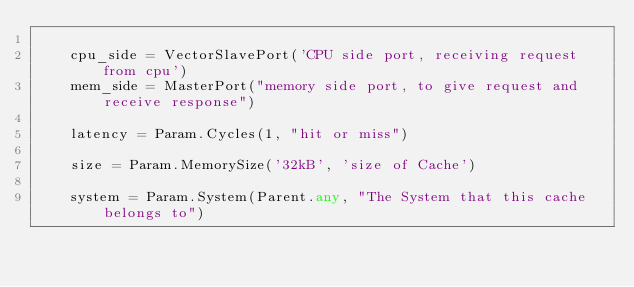<code> <loc_0><loc_0><loc_500><loc_500><_Python_>
    cpu_side = VectorSlavePort('CPU side port, receiving request from cpu')
    mem_side = MasterPort("memory side port, to give request and receive response")

    latency = Param.Cycles(1, "hit or miss")

    size = Param.MemorySize('32kB', 'size of Cache')

    system = Param.System(Parent.any, "The System that this cache belongs to")

</code> 